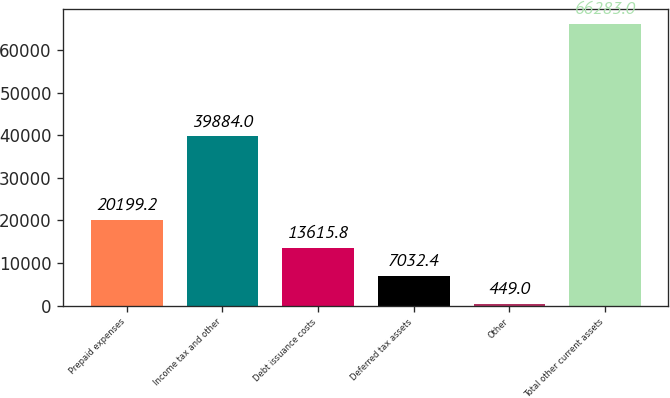<chart> <loc_0><loc_0><loc_500><loc_500><bar_chart><fcel>Prepaid expenses<fcel>Income tax and other<fcel>Debt issuance costs<fcel>Deferred tax assets<fcel>Other<fcel>Total other current assets<nl><fcel>20199.2<fcel>39884<fcel>13615.8<fcel>7032.4<fcel>449<fcel>66283<nl></chart> 